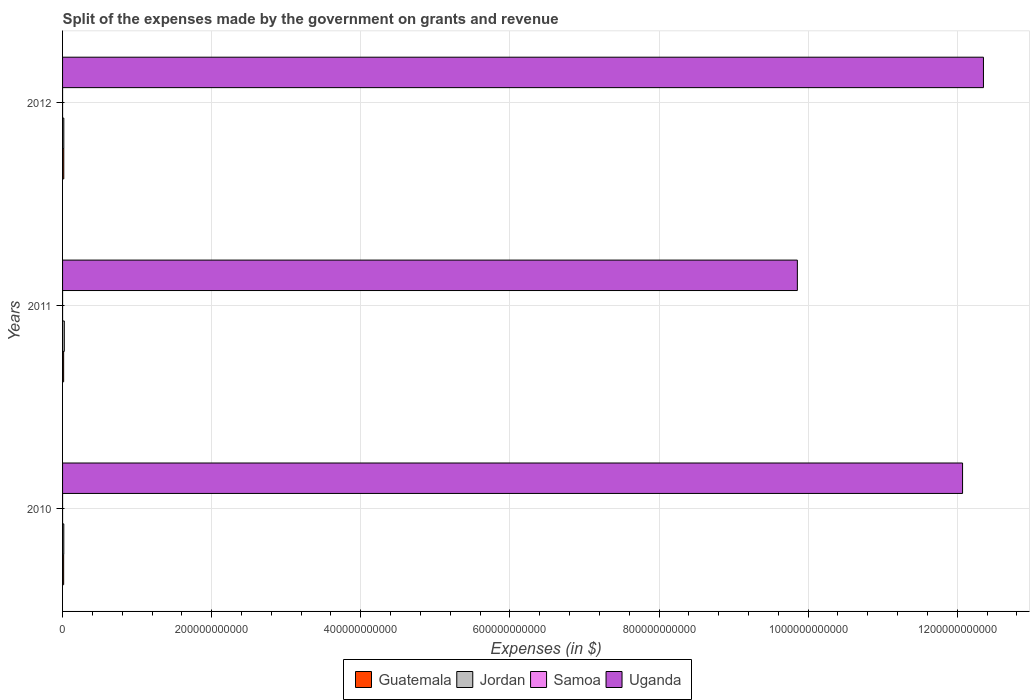How many groups of bars are there?
Your answer should be very brief. 3. Are the number of bars per tick equal to the number of legend labels?
Give a very brief answer. Yes. Are the number of bars on each tick of the Y-axis equal?
Offer a terse response. Yes. How many bars are there on the 3rd tick from the top?
Ensure brevity in your answer.  4. What is the label of the 1st group of bars from the top?
Your answer should be very brief. 2012. In how many cases, is the number of bars for a given year not equal to the number of legend labels?
Your answer should be compact. 0. What is the expenses made by the government on grants and revenue in Guatemala in 2010?
Provide a succinct answer. 1.47e+09. Across all years, what is the maximum expenses made by the government on grants and revenue in Guatemala?
Give a very brief answer. 1.64e+09. Across all years, what is the minimum expenses made by the government on grants and revenue in Guatemala?
Offer a very short reply. 1.44e+09. What is the total expenses made by the government on grants and revenue in Samoa in the graph?
Make the answer very short. 2.32e+05. What is the difference between the expenses made by the government on grants and revenue in Guatemala in 2010 and that in 2012?
Offer a terse response. -1.70e+08. What is the difference between the expenses made by the government on grants and revenue in Samoa in 2011 and the expenses made by the government on grants and revenue in Uganda in 2012?
Give a very brief answer. -1.24e+12. What is the average expenses made by the government on grants and revenue in Jordan per year?
Provide a succinct answer. 1.89e+09. In the year 2010, what is the difference between the expenses made by the government on grants and revenue in Samoa and expenses made by the government on grants and revenue in Jordan?
Ensure brevity in your answer.  -1.66e+09. In how many years, is the expenses made by the government on grants and revenue in Uganda greater than 1240000000000 $?
Offer a terse response. 0. What is the ratio of the expenses made by the government on grants and revenue in Uganda in 2011 to that in 2012?
Give a very brief answer. 0.8. What is the difference between the highest and the second highest expenses made by the government on grants and revenue in Guatemala?
Your response must be concise. 1.70e+08. What is the difference between the highest and the lowest expenses made by the government on grants and revenue in Samoa?
Provide a short and direct response. 3.13e+04. In how many years, is the expenses made by the government on grants and revenue in Jordan greater than the average expenses made by the government on grants and revenue in Jordan taken over all years?
Offer a terse response. 1. What does the 1st bar from the top in 2012 represents?
Provide a short and direct response. Uganda. What does the 4th bar from the bottom in 2012 represents?
Your response must be concise. Uganda. How many bars are there?
Your answer should be compact. 12. Are all the bars in the graph horizontal?
Provide a succinct answer. Yes. How many years are there in the graph?
Provide a succinct answer. 3. What is the difference between two consecutive major ticks on the X-axis?
Offer a terse response. 2.00e+11. Are the values on the major ticks of X-axis written in scientific E-notation?
Your answer should be very brief. No. Does the graph contain grids?
Provide a short and direct response. Yes. How many legend labels are there?
Your answer should be compact. 4. How are the legend labels stacked?
Offer a very short reply. Horizontal. What is the title of the graph?
Keep it short and to the point. Split of the expenses made by the government on grants and revenue. What is the label or title of the X-axis?
Offer a very short reply. Expenses (in $). What is the label or title of the Y-axis?
Give a very brief answer. Years. What is the Expenses (in $) in Guatemala in 2010?
Ensure brevity in your answer.  1.47e+09. What is the Expenses (in $) of Jordan in 2010?
Give a very brief answer. 1.66e+09. What is the Expenses (in $) of Samoa in 2010?
Your answer should be very brief. 5.86e+04. What is the Expenses (in $) in Uganda in 2010?
Make the answer very short. 1.21e+12. What is the Expenses (in $) in Guatemala in 2011?
Offer a terse response. 1.44e+09. What is the Expenses (in $) in Jordan in 2011?
Provide a short and direct response. 2.33e+09. What is the Expenses (in $) in Samoa in 2011?
Keep it short and to the point. 8.31e+04. What is the Expenses (in $) of Uganda in 2011?
Offer a terse response. 9.86e+11. What is the Expenses (in $) of Guatemala in 2012?
Your answer should be compact. 1.64e+09. What is the Expenses (in $) of Jordan in 2012?
Offer a terse response. 1.68e+09. What is the Expenses (in $) of Samoa in 2012?
Provide a short and direct response. 8.99e+04. What is the Expenses (in $) in Uganda in 2012?
Your answer should be compact. 1.24e+12. Across all years, what is the maximum Expenses (in $) in Guatemala?
Offer a terse response. 1.64e+09. Across all years, what is the maximum Expenses (in $) of Jordan?
Your response must be concise. 2.33e+09. Across all years, what is the maximum Expenses (in $) in Samoa?
Your answer should be compact. 8.99e+04. Across all years, what is the maximum Expenses (in $) in Uganda?
Your answer should be very brief. 1.24e+12. Across all years, what is the minimum Expenses (in $) of Guatemala?
Your answer should be very brief. 1.44e+09. Across all years, what is the minimum Expenses (in $) in Jordan?
Give a very brief answer. 1.66e+09. Across all years, what is the minimum Expenses (in $) of Samoa?
Offer a terse response. 5.86e+04. Across all years, what is the minimum Expenses (in $) of Uganda?
Ensure brevity in your answer.  9.86e+11. What is the total Expenses (in $) in Guatemala in the graph?
Offer a very short reply. 4.54e+09. What is the total Expenses (in $) of Jordan in the graph?
Your answer should be compact. 5.67e+09. What is the total Expenses (in $) of Samoa in the graph?
Offer a very short reply. 2.32e+05. What is the total Expenses (in $) of Uganda in the graph?
Make the answer very short. 3.43e+12. What is the difference between the Expenses (in $) of Guatemala in 2010 and that in 2011?
Give a very brief answer. 2.46e+07. What is the difference between the Expenses (in $) in Jordan in 2010 and that in 2011?
Provide a succinct answer. -6.75e+08. What is the difference between the Expenses (in $) of Samoa in 2010 and that in 2011?
Offer a very short reply. -2.44e+04. What is the difference between the Expenses (in $) of Uganda in 2010 and that in 2011?
Provide a succinct answer. 2.22e+11. What is the difference between the Expenses (in $) in Guatemala in 2010 and that in 2012?
Your answer should be compact. -1.70e+08. What is the difference between the Expenses (in $) of Jordan in 2010 and that in 2012?
Offer a terse response. -2.25e+07. What is the difference between the Expenses (in $) in Samoa in 2010 and that in 2012?
Provide a succinct answer. -3.13e+04. What is the difference between the Expenses (in $) in Uganda in 2010 and that in 2012?
Your answer should be compact. -2.80e+1. What is the difference between the Expenses (in $) in Guatemala in 2011 and that in 2012?
Your answer should be very brief. -1.95e+08. What is the difference between the Expenses (in $) of Jordan in 2011 and that in 2012?
Your answer should be compact. 6.52e+08. What is the difference between the Expenses (in $) in Samoa in 2011 and that in 2012?
Your answer should be compact. -6851.45. What is the difference between the Expenses (in $) in Uganda in 2011 and that in 2012?
Provide a succinct answer. -2.50e+11. What is the difference between the Expenses (in $) of Guatemala in 2010 and the Expenses (in $) of Jordan in 2011?
Provide a short and direct response. -8.66e+08. What is the difference between the Expenses (in $) of Guatemala in 2010 and the Expenses (in $) of Samoa in 2011?
Your answer should be very brief. 1.47e+09. What is the difference between the Expenses (in $) of Guatemala in 2010 and the Expenses (in $) of Uganda in 2011?
Give a very brief answer. -9.84e+11. What is the difference between the Expenses (in $) in Jordan in 2010 and the Expenses (in $) in Samoa in 2011?
Provide a short and direct response. 1.66e+09. What is the difference between the Expenses (in $) in Jordan in 2010 and the Expenses (in $) in Uganda in 2011?
Give a very brief answer. -9.84e+11. What is the difference between the Expenses (in $) of Samoa in 2010 and the Expenses (in $) of Uganda in 2011?
Your response must be concise. -9.86e+11. What is the difference between the Expenses (in $) in Guatemala in 2010 and the Expenses (in $) in Jordan in 2012?
Ensure brevity in your answer.  -2.13e+08. What is the difference between the Expenses (in $) in Guatemala in 2010 and the Expenses (in $) in Samoa in 2012?
Offer a terse response. 1.47e+09. What is the difference between the Expenses (in $) in Guatemala in 2010 and the Expenses (in $) in Uganda in 2012?
Your answer should be very brief. -1.23e+12. What is the difference between the Expenses (in $) in Jordan in 2010 and the Expenses (in $) in Samoa in 2012?
Keep it short and to the point. 1.66e+09. What is the difference between the Expenses (in $) in Jordan in 2010 and the Expenses (in $) in Uganda in 2012?
Make the answer very short. -1.23e+12. What is the difference between the Expenses (in $) in Samoa in 2010 and the Expenses (in $) in Uganda in 2012?
Give a very brief answer. -1.24e+12. What is the difference between the Expenses (in $) of Guatemala in 2011 and the Expenses (in $) of Jordan in 2012?
Give a very brief answer. -2.38e+08. What is the difference between the Expenses (in $) of Guatemala in 2011 and the Expenses (in $) of Samoa in 2012?
Make the answer very short. 1.44e+09. What is the difference between the Expenses (in $) in Guatemala in 2011 and the Expenses (in $) in Uganda in 2012?
Your answer should be compact. -1.23e+12. What is the difference between the Expenses (in $) in Jordan in 2011 and the Expenses (in $) in Samoa in 2012?
Your response must be concise. 2.33e+09. What is the difference between the Expenses (in $) in Jordan in 2011 and the Expenses (in $) in Uganda in 2012?
Offer a terse response. -1.23e+12. What is the difference between the Expenses (in $) of Samoa in 2011 and the Expenses (in $) of Uganda in 2012?
Ensure brevity in your answer.  -1.24e+12. What is the average Expenses (in $) in Guatemala per year?
Ensure brevity in your answer.  1.51e+09. What is the average Expenses (in $) of Jordan per year?
Your answer should be very brief. 1.89e+09. What is the average Expenses (in $) of Samoa per year?
Your answer should be compact. 7.72e+04. What is the average Expenses (in $) of Uganda per year?
Ensure brevity in your answer.  1.14e+12. In the year 2010, what is the difference between the Expenses (in $) in Guatemala and Expenses (in $) in Jordan?
Make the answer very short. -1.91e+08. In the year 2010, what is the difference between the Expenses (in $) in Guatemala and Expenses (in $) in Samoa?
Make the answer very short. 1.47e+09. In the year 2010, what is the difference between the Expenses (in $) of Guatemala and Expenses (in $) of Uganda?
Keep it short and to the point. -1.21e+12. In the year 2010, what is the difference between the Expenses (in $) of Jordan and Expenses (in $) of Samoa?
Provide a short and direct response. 1.66e+09. In the year 2010, what is the difference between the Expenses (in $) in Jordan and Expenses (in $) in Uganda?
Provide a succinct answer. -1.21e+12. In the year 2010, what is the difference between the Expenses (in $) in Samoa and Expenses (in $) in Uganda?
Offer a very short reply. -1.21e+12. In the year 2011, what is the difference between the Expenses (in $) of Guatemala and Expenses (in $) of Jordan?
Your answer should be compact. -8.90e+08. In the year 2011, what is the difference between the Expenses (in $) in Guatemala and Expenses (in $) in Samoa?
Your response must be concise. 1.44e+09. In the year 2011, what is the difference between the Expenses (in $) in Guatemala and Expenses (in $) in Uganda?
Your response must be concise. -9.84e+11. In the year 2011, what is the difference between the Expenses (in $) in Jordan and Expenses (in $) in Samoa?
Provide a succinct answer. 2.33e+09. In the year 2011, what is the difference between the Expenses (in $) in Jordan and Expenses (in $) in Uganda?
Your answer should be compact. -9.83e+11. In the year 2011, what is the difference between the Expenses (in $) of Samoa and Expenses (in $) of Uganda?
Keep it short and to the point. -9.86e+11. In the year 2012, what is the difference between the Expenses (in $) of Guatemala and Expenses (in $) of Jordan?
Ensure brevity in your answer.  -4.29e+07. In the year 2012, what is the difference between the Expenses (in $) in Guatemala and Expenses (in $) in Samoa?
Ensure brevity in your answer.  1.64e+09. In the year 2012, what is the difference between the Expenses (in $) in Guatemala and Expenses (in $) in Uganda?
Keep it short and to the point. -1.23e+12. In the year 2012, what is the difference between the Expenses (in $) in Jordan and Expenses (in $) in Samoa?
Give a very brief answer. 1.68e+09. In the year 2012, what is the difference between the Expenses (in $) in Jordan and Expenses (in $) in Uganda?
Provide a succinct answer. -1.23e+12. In the year 2012, what is the difference between the Expenses (in $) of Samoa and Expenses (in $) of Uganda?
Provide a succinct answer. -1.24e+12. What is the ratio of the Expenses (in $) of Guatemala in 2010 to that in 2011?
Make the answer very short. 1.02. What is the ratio of the Expenses (in $) of Jordan in 2010 to that in 2011?
Provide a succinct answer. 0.71. What is the ratio of the Expenses (in $) in Samoa in 2010 to that in 2011?
Ensure brevity in your answer.  0.71. What is the ratio of the Expenses (in $) of Uganda in 2010 to that in 2011?
Offer a terse response. 1.22. What is the ratio of the Expenses (in $) in Guatemala in 2010 to that in 2012?
Ensure brevity in your answer.  0.9. What is the ratio of the Expenses (in $) in Jordan in 2010 to that in 2012?
Ensure brevity in your answer.  0.99. What is the ratio of the Expenses (in $) in Samoa in 2010 to that in 2012?
Make the answer very short. 0.65. What is the ratio of the Expenses (in $) of Uganda in 2010 to that in 2012?
Your answer should be very brief. 0.98. What is the ratio of the Expenses (in $) in Guatemala in 2011 to that in 2012?
Your answer should be compact. 0.88. What is the ratio of the Expenses (in $) in Jordan in 2011 to that in 2012?
Your answer should be compact. 1.39. What is the ratio of the Expenses (in $) in Samoa in 2011 to that in 2012?
Keep it short and to the point. 0.92. What is the ratio of the Expenses (in $) of Uganda in 2011 to that in 2012?
Give a very brief answer. 0.8. What is the difference between the highest and the second highest Expenses (in $) in Guatemala?
Ensure brevity in your answer.  1.70e+08. What is the difference between the highest and the second highest Expenses (in $) of Jordan?
Your answer should be very brief. 6.52e+08. What is the difference between the highest and the second highest Expenses (in $) in Samoa?
Give a very brief answer. 6851.45. What is the difference between the highest and the second highest Expenses (in $) of Uganda?
Your response must be concise. 2.80e+1. What is the difference between the highest and the lowest Expenses (in $) of Guatemala?
Keep it short and to the point. 1.95e+08. What is the difference between the highest and the lowest Expenses (in $) of Jordan?
Give a very brief answer. 6.75e+08. What is the difference between the highest and the lowest Expenses (in $) of Samoa?
Provide a succinct answer. 3.13e+04. What is the difference between the highest and the lowest Expenses (in $) in Uganda?
Offer a very short reply. 2.50e+11. 